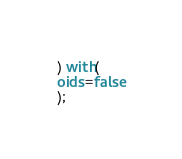<code> <loc_0><loc_0><loc_500><loc_500><_SQL_>) with(
oids=false
);</code> 